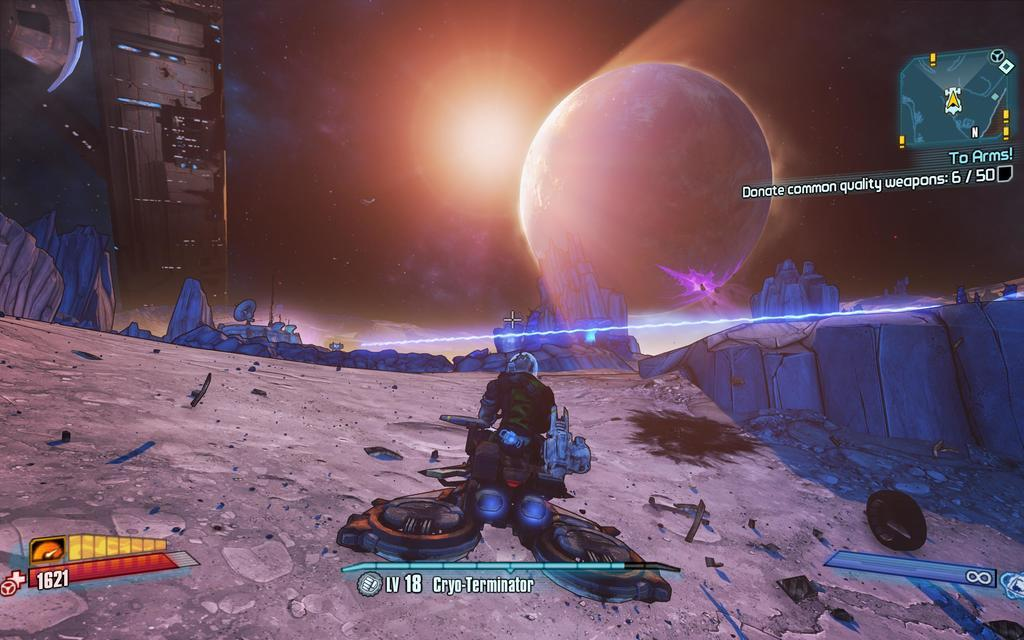What type of image is shown in the screenshot? The image is a screenshot of a game. What sound does the doll make when it is clicked in the game? There is no doll present in the game, as the image only shows a screenshot of a game without any specific details about the game's content. 